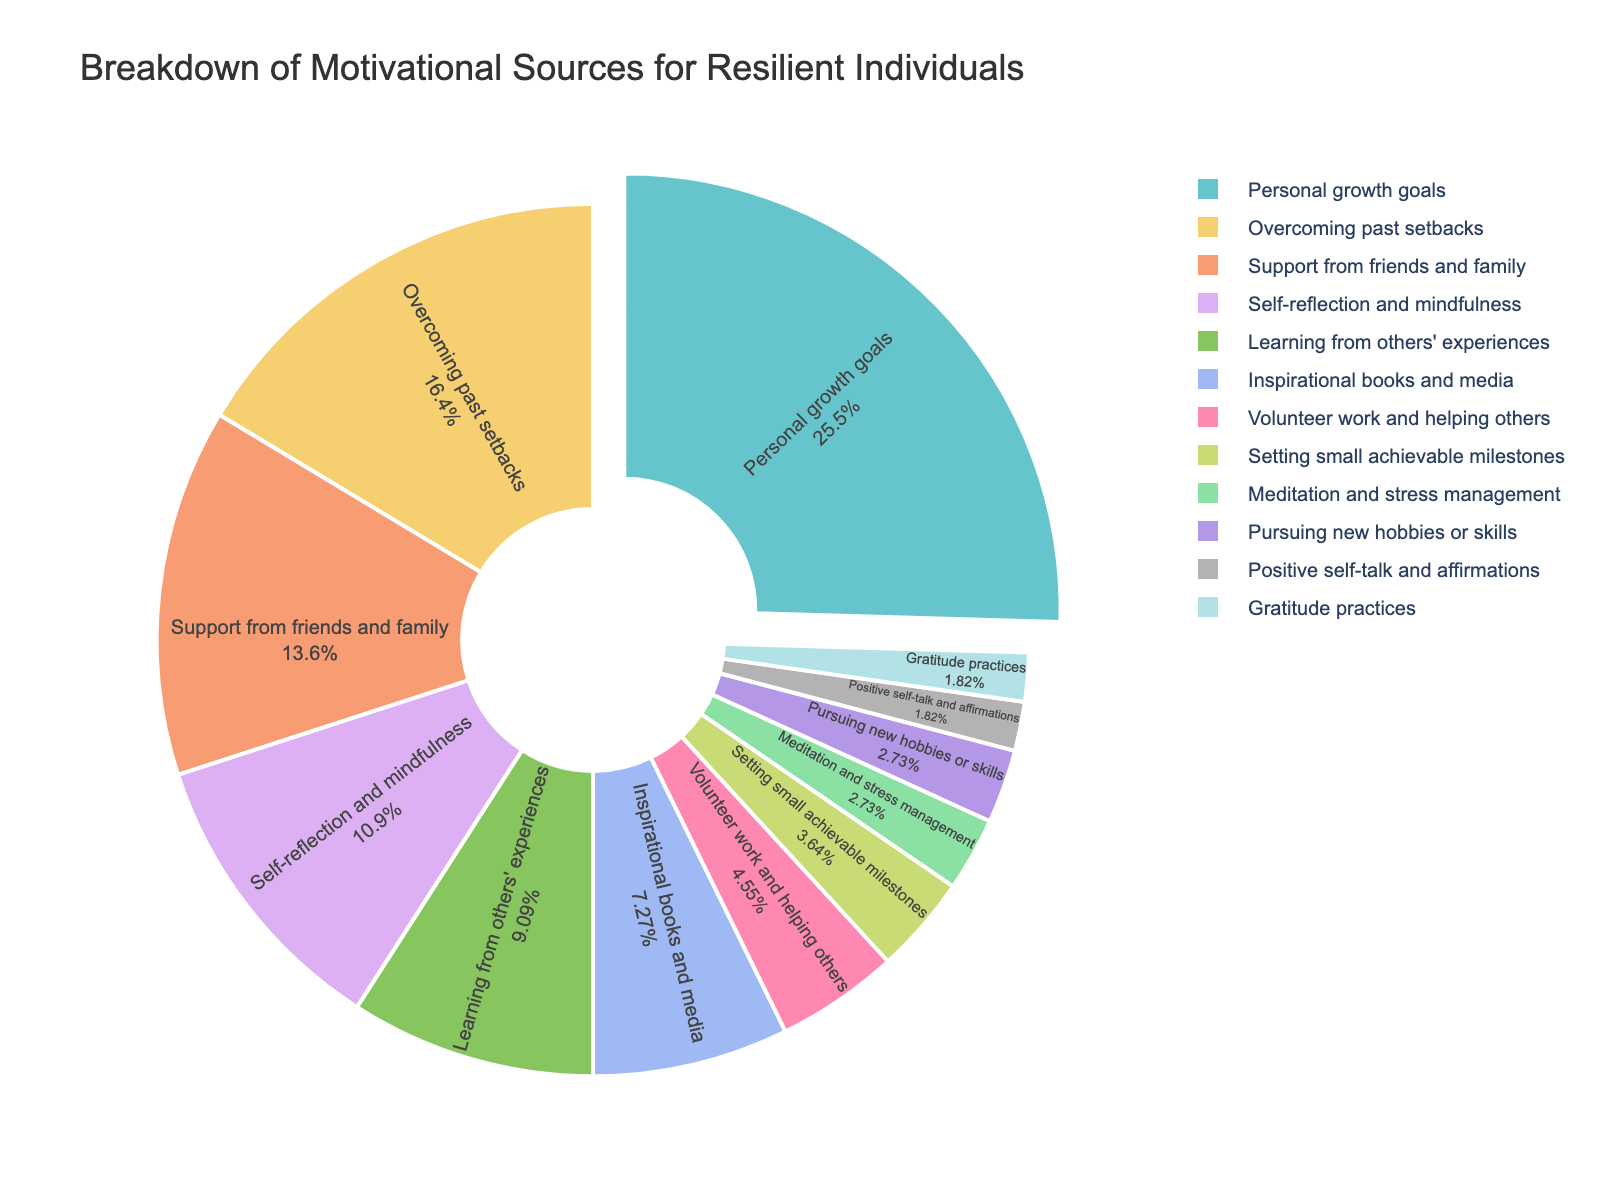What is the largest motivational source for resilient individuals? The figure shows the percentage breakdown of various motivational sources. The source with the highest percentage will be the largest motivational source.
Answer: Personal growth goals Which source contributes more, 'Overcoming past setbacks' or 'Support from friends and family'? Refer to the figure and identify the percentages for 'Overcoming past setbacks' (18%) and 'Support from friends and family' (15%). Compare the two values.
Answer: Overcoming past setbacks What is the total percentage of motivation derived from 'Volunteer work and helping others', 'Setting small achievable milestones', and 'Pursuing new hobbies or skills'? Add up the percentages of 'Volunteer work and helping others' (5%), 'Setting small achievable milestones' (4%), and 'Pursuing new hobbies or skills' (3%). The total is 5% + 4% + 3% = 12%.
Answer: 12% Which source has the smallest contribution, and what is its percentage? Look for the source with the lowest percentage in the figure. Both 'Positive self-talk and affirmations' and 'Gratitude practices' have the smallest value.
Answer: Positive self-talk and affirmations & Gratitude practices, 2% How much more does 'Learning from others' experiences' contribute compared to 'Inspirational books and media'? Determine the percentages for 'Learning from others' experiences' (10%) and 'Inspirational books and media' (8%) then calculate the difference. 10% - 8% = 2%.
Answer: 2% Which three sources collectively make up the largest portion of the motivational breakdown? Identify the top three sources with the highest percentages from the figure: 'Personal growth goals' (28%), 'Overcoming past setbacks' (18%), and 'Support from friends and family' (15%).
Answer: Personal growth goals, Overcoming past setbacks, Support from friends and family What percentage of motivation comes from 'Inspirational books and media' and 'Gratitude practices' combined? Sum the percentages of 'Inspirational books and media' (8%) and 'Gratitude practices' (2%). The sum is 8% + 2% = 10%.
Answer: 10% Is the combined percentage of 'Self-reflection and mindfulness' and 'Meditation and stress management' greater than the percentage for 'Overcoming past setbacks'? Add the percentages of 'Self-reflection and mindfulness' (12%) and 'Meditation and stress management' (3%), and then compare this sum (15%) to 'Overcoming past setbacks' (18%).
Answer: No What is the difference in percentage between 'Support from friends and family' and 'Learning from others' experiences'? Calculate the difference between the two percentages: 'Support from friends and family' (15%) and 'Learning from others' experiences' (10%). 15% - 10% = 5%.
Answer: 5% Which source, 'Setting small achievable milestones' or 'Gratitude practices', has a higher percentage, and by how much? Compare the percentages for 'Setting small achievable milestones' (4%) and 'Gratitude practices' (2%), then find the difference. 4% - 2% = 2%.
Answer: Setting small achievable milestones, 2% 